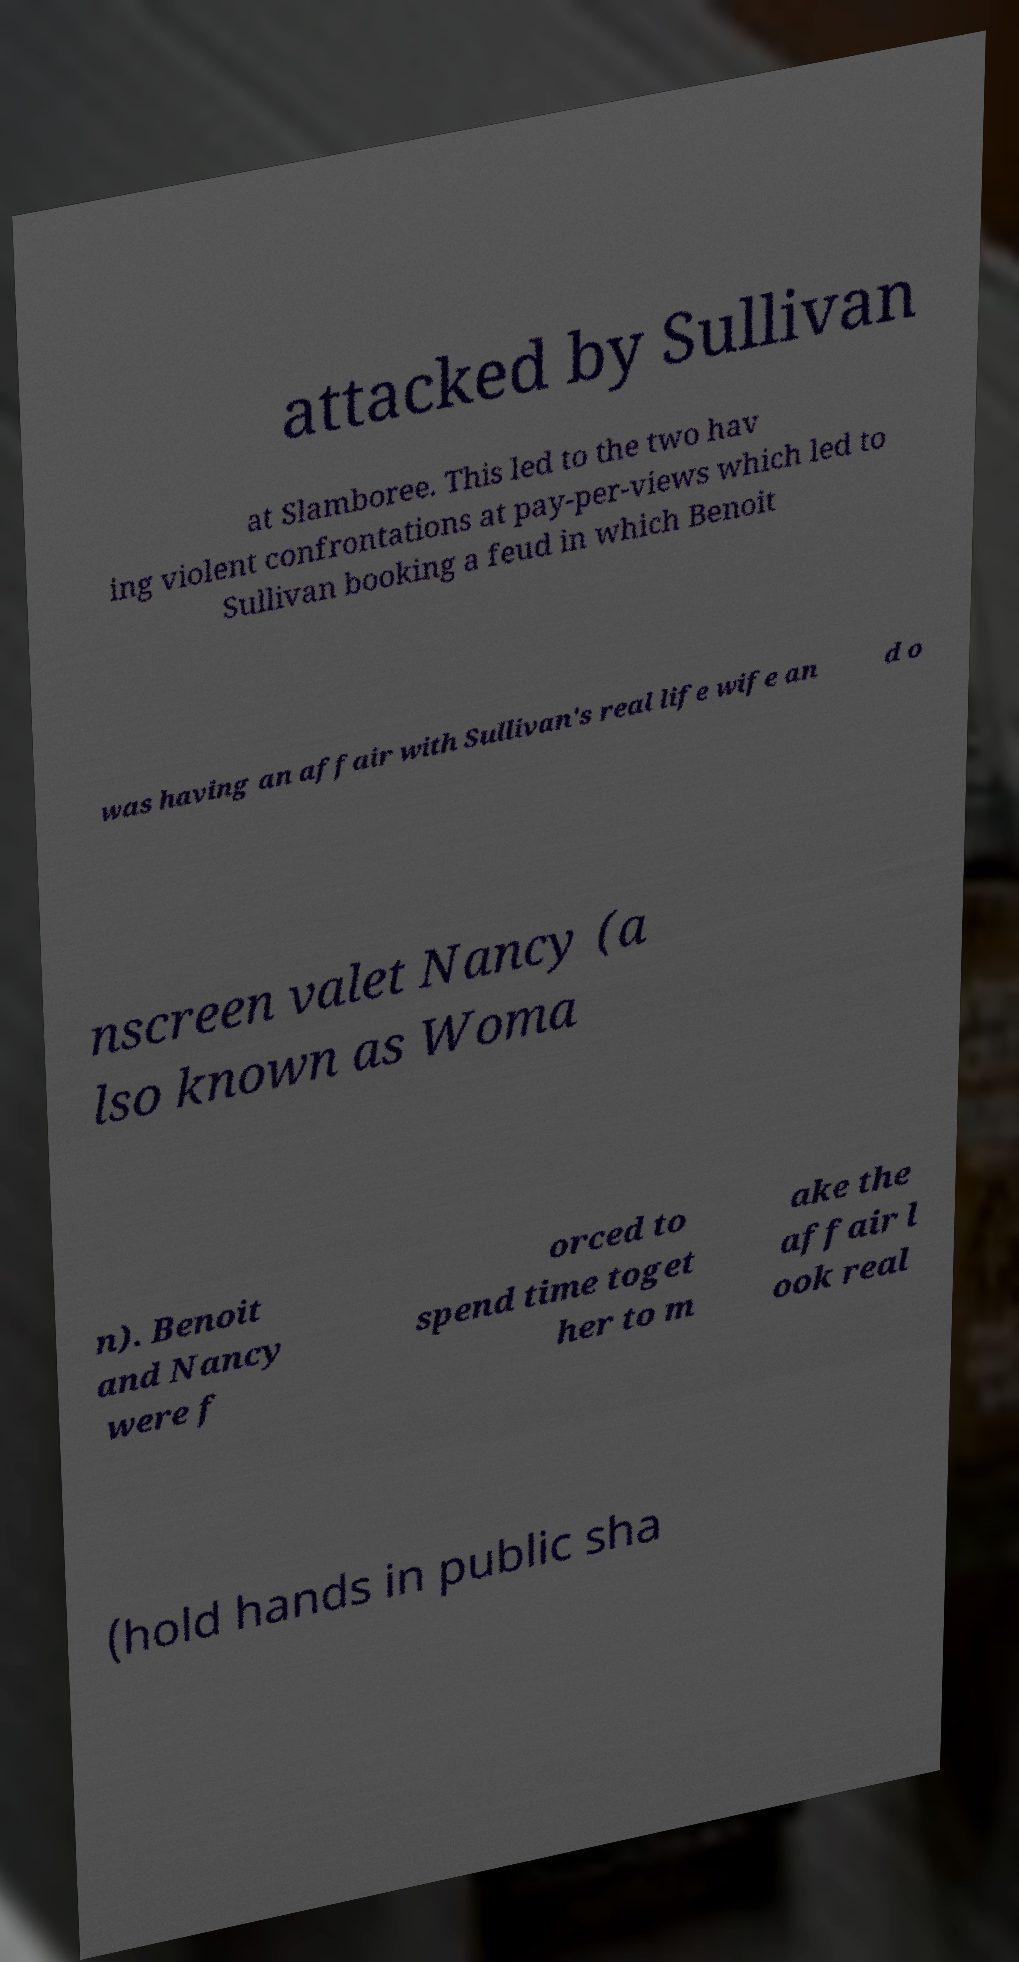Can you read and provide the text displayed in the image?This photo seems to have some interesting text. Can you extract and type it out for me? attacked by Sullivan at Slamboree. This led to the two hav ing violent confrontations at pay-per-views which led to Sullivan booking a feud in which Benoit was having an affair with Sullivan's real life wife an d o nscreen valet Nancy (a lso known as Woma n). Benoit and Nancy were f orced to spend time toget her to m ake the affair l ook real (hold hands in public sha 